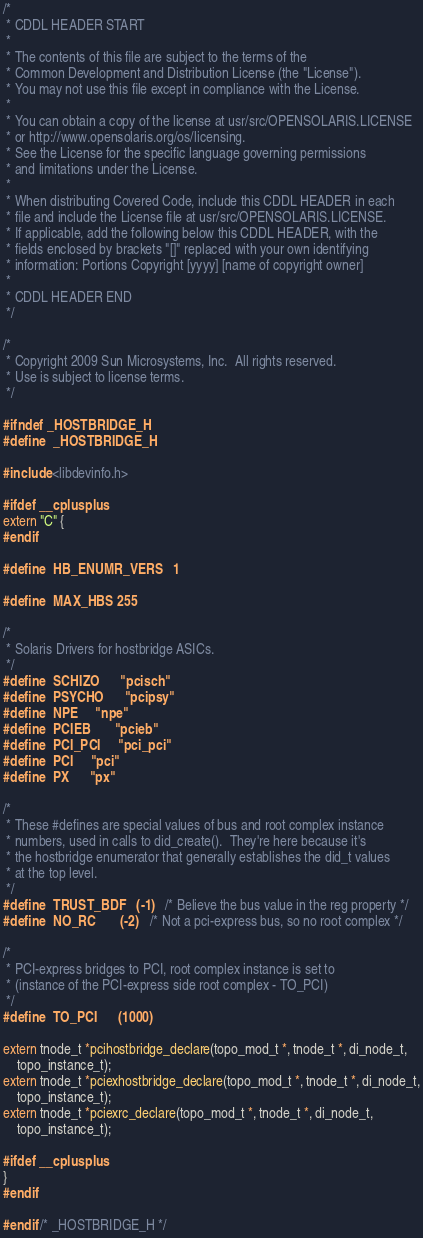<code> <loc_0><loc_0><loc_500><loc_500><_C_>/*
 * CDDL HEADER START
 *
 * The contents of this file are subject to the terms of the
 * Common Development and Distribution License (the "License").
 * You may not use this file except in compliance with the License.
 *
 * You can obtain a copy of the license at usr/src/OPENSOLARIS.LICENSE
 * or http://www.opensolaris.org/os/licensing.
 * See the License for the specific language governing permissions
 * and limitations under the License.
 *
 * When distributing Covered Code, include this CDDL HEADER in each
 * file and include the License file at usr/src/OPENSOLARIS.LICENSE.
 * If applicable, add the following below this CDDL HEADER, with the
 * fields enclosed by brackets "[]" replaced with your own identifying
 * information: Portions Copyright [yyyy] [name of copyright owner]
 *
 * CDDL HEADER END
 */

/*
 * Copyright 2009 Sun Microsystems, Inc.  All rights reserved.
 * Use is subject to license terms.
 */

#ifndef _HOSTBRIDGE_H
#define	_HOSTBRIDGE_H

#include <libdevinfo.h>

#ifdef __cplusplus
extern "C" {
#endif

#define	HB_ENUMR_VERS	1

#define	MAX_HBS	255

/*
 * Solaris Drivers for hostbridge ASICs.
 */
#define	SCHIZO		"pcisch"
#define	PSYCHO		"pcipsy"
#define	NPE		"npe"
#define	PCIEB		"pcieb"
#define	PCI_PCI		"pci_pci"
#define	PCI		"pci"
#define	PX		"px"

/*
 * These #defines are special values of bus and root complex instance
 * numbers, used in calls to did_create().  They're here because it's
 * the hostbridge enumerator that generally establishes the did_t values
 * at the top level.
 */
#define	TRUST_BDF	(-1)	/* Believe the bus value in the reg property */
#define	NO_RC		(-2)	/* Not a pci-express bus, so no root complex */

/*
 * PCI-express bridges to PCI, root complex instance is set to
 * (instance of the PCI-express side root complex - TO_PCI)
 */
#define	TO_PCI		(1000)

extern tnode_t *pcihostbridge_declare(topo_mod_t *, tnode_t *, di_node_t,
    topo_instance_t);
extern tnode_t *pciexhostbridge_declare(topo_mod_t *, tnode_t *, di_node_t,
    topo_instance_t);
extern tnode_t *pciexrc_declare(topo_mod_t *, tnode_t *, di_node_t,
    topo_instance_t);

#ifdef __cplusplus
}
#endif

#endif /* _HOSTBRIDGE_H */
</code> 